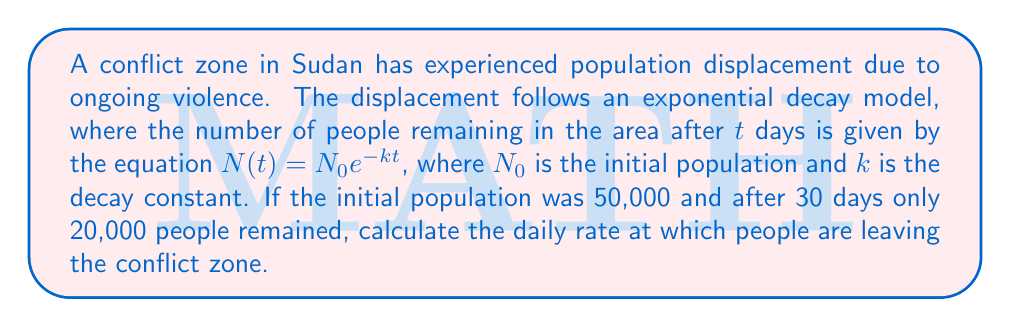Can you solve this math problem? 1. We are given the exponential decay model: $N(t) = N_0e^{-kt}$

2. We know:
   $N_0 = 50,000$ (initial population)
   $N(30) = 20,000$ (population after 30 days)
   $t = 30$ days

3. Substitute these values into the equation:
   $20,000 = 50,000e^{-k(30)}$

4. Simplify:
   $\frac{20,000}{50,000} = e^{-30k}$
   $0.4 = e^{-30k}$

5. Take the natural logarithm of both sides:
   $\ln(0.4) = \ln(e^{-30k})$
   $\ln(0.4) = -30k$

6. Solve for $k$:
   $k = -\frac{\ln(0.4)}{30}$
   $k \approx 0.0306$

7. The daily rate at which people are leaving is $1 - e^{-k}$:
   $1 - e^{-0.0306} \approx 0.0301$ or 3.01%
Answer: 3.01% 